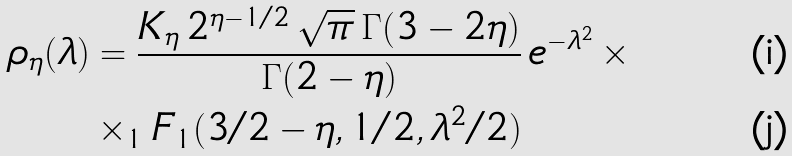<formula> <loc_0><loc_0><loc_500><loc_500>\rho _ { \eta } ( \lambda ) & = \frac { K _ { \eta } \, 2 ^ { \eta - 1 / 2 } \, \sqrt { \pi } \, \Gamma ( 3 - 2 \eta ) } { \Gamma ( 2 - \eta ) } \, e ^ { - \lambda ^ { 2 } } \, \times \\ & \times _ { 1 } F _ { 1 } ( 3 / 2 - \eta , 1 / 2 , \lambda ^ { 2 } / 2 )</formula> 